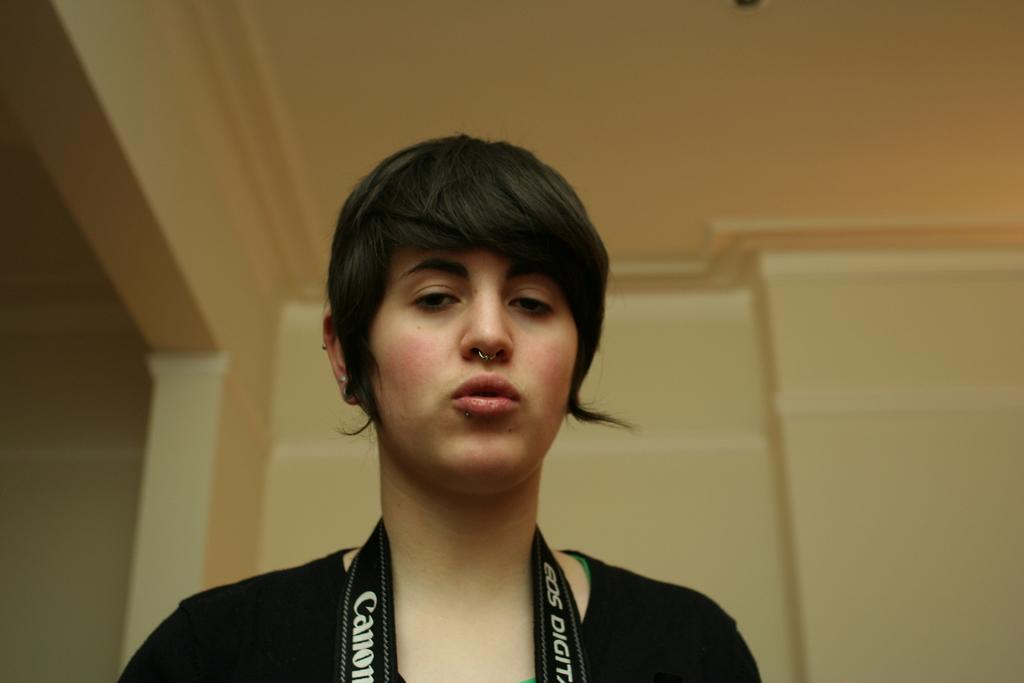Who is the main subject in the foreground of the picture? There is a woman in the foreground of the picture. What is the woman wearing around her neck? The woman is wearing a belt-like object around her neck. What can be seen in the background of the picture? There is a well in the background of the picture. What part of the room is visible at the top of the picture? The ceiling is visible at the top of the picture. What type of club is the woman holding in the picture? There is no club visible in the picture; the woman is wearing a belt-like object around her neck. How many buns are on the woman's head in the picture? There are no buns visible on the woman's head in the picture. 